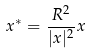<formula> <loc_0><loc_0><loc_500><loc_500>x ^ { * } = \frac { R ^ { 2 } } { | x | ^ { 2 } } x</formula> 